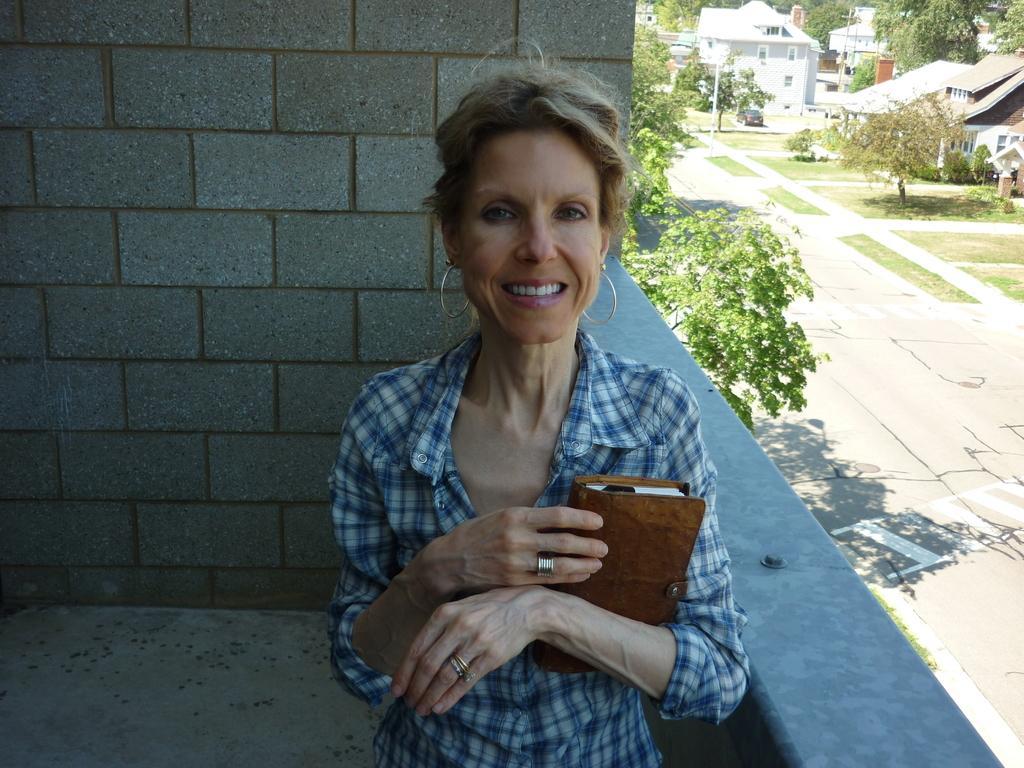Please provide a concise description of this image. In this picture there is a woman wearing a blue and white color shirt, holding a book in her hands. She is smiling. We can observe a wall behind her. On the right side there is a path. We can observe some buildings here. There are some trees. 